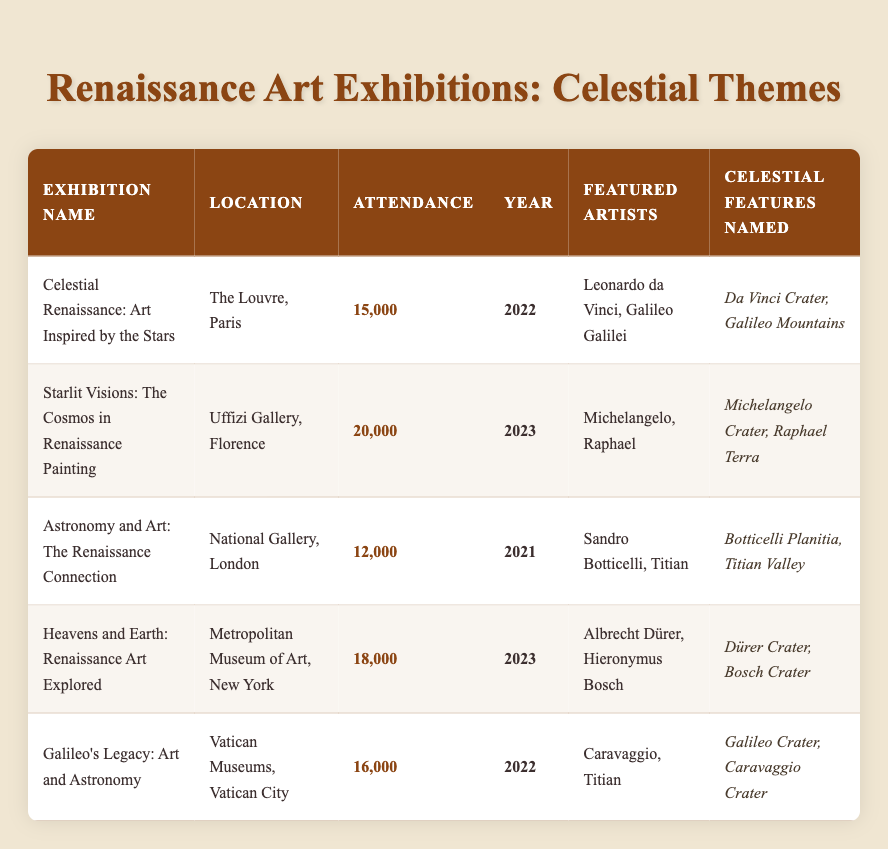What was the highest attendance among the exhibitions? By examining the attendance column in the table, the highest value is 20,000, which is associated with the exhibition "Starlit Visions: The Cosmos in Renaissance Painting."
Answer: 20,000 Which exhibition took place in 2021? Looking at the year column, the exhibition "Astronomy and Art: The Renaissance Connection" is the only one listed for the year 2021.
Answer: Astronomy and Art: The Renaissance Connection What is the total attendance for exhibitions held in 2022? The exhibitions in 2022 include "Celestial Renaissance: Art Inspired by the Stars" (15,000) and "Galileo's Legacy: Art and Astronomy" (16,000). Adding these together: 15,000 + 16,000 = 31,000.
Answer: 31,000 Was there an exhibition featuring Michelangelo? Checking the featured artists for each exhibition, "Starlit Visions: The Cosmos in Renaissance Painting" includes Michelangelo, confirming he was featured.
Answer: Yes How many celestial features were named for artists featured in exhibitions in 2023? In 2023, there are two exhibitions: "Starlit Visions: The Cosmos in Renaissance Painting" (Michelangelo Crater, Raphael Terra) and "Heavens and Earth: Renaissance Art Explored" (Dürer Crater, Bosch Crater). This totals four celestial features named after the involved artists.
Answer: 4 What is the average attendance for all listed exhibitions? To find the average, we sum all attendance figures: 15,000 + 20,000 + 12,000 + 18,000 + 16,000 = 81,000. There are 5 exhibitions, so the average is 81,000 / 5 = 16,200.
Answer: 16,200 Which exhibition had the lowest attendance and where was it located? Upon review, "Astronomy and Art: The Renaissance Connection" has the lowest attendance of 12,000, held at the National Gallery in London.
Answer: Astronomy and Art: The Renaissance Connection, National Gallery, London Are there any exhibitions featuring both Titian and Galileo? Checking the featured artists, Titian is listed in both "Astronomy and Art: The Renaissance Connection" and "Galileo's Legacy: Art and Astronomy," but Galileo only appears in "Celestial Renaissance: Art Inspired by the Stars" and "Galileo's Legacy: Art and Astronomy." Thus, the answer is no as they do not share the same exhibition.
Answer: No 